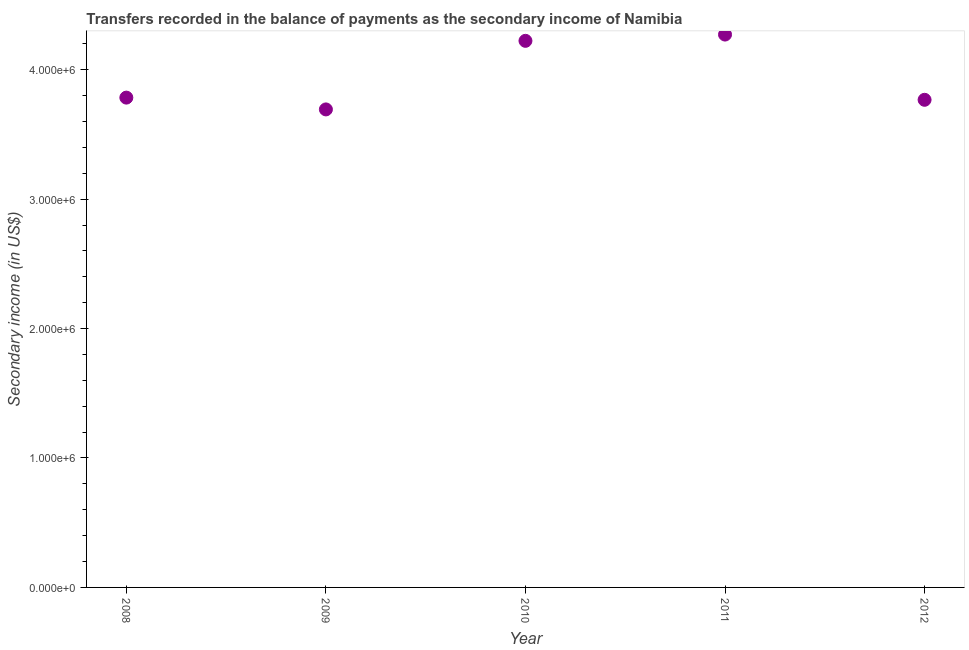What is the amount of secondary income in 2012?
Provide a short and direct response. 3.77e+06. Across all years, what is the maximum amount of secondary income?
Give a very brief answer. 4.27e+06. Across all years, what is the minimum amount of secondary income?
Provide a short and direct response. 3.69e+06. In which year was the amount of secondary income minimum?
Your answer should be compact. 2009. What is the sum of the amount of secondary income?
Offer a terse response. 1.97e+07. What is the difference between the amount of secondary income in 2010 and 2011?
Make the answer very short. -4.85e+04. What is the average amount of secondary income per year?
Your answer should be compact. 3.95e+06. What is the median amount of secondary income?
Your response must be concise. 3.78e+06. What is the ratio of the amount of secondary income in 2009 to that in 2010?
Offer a very short reply. 0.87. Is the amount of secondary income in 2008 less than that in 2011?
Give a very brief answer. Yes. Is the difference between the amount of secondary income in 2009 and 2010 greater than the difference between any two years?
Give a very brief answer. No. What is the difference between the highest and the second highest amount of secondary income?
Your answer should be very brief. 4.85e+04. Is the sum of the amount of secondary income in 2008 and 2009 greater than the maximum amount of secondary income across all years?
Provide a short and direct response. Yes. What is the difference between the highest and the lowest amount of secondary income?
Your answer should be compact. 5.78e+05. Does the amount of secondary income monotonically increase over the years?
Offer a very short reply. No. How many years are there in the graph?
Give a very brief answer. 5. What is the difference between two consecutive major ticks on the Y-axis?
Keep it short and to the point. 1.00e+06. Are the values on the major ticks of Y-axis written in scientific E-notation?
Provide a short and direct response. Yes. What is the title of the graph?
Your response must be concise. Transfers recorded in the balance of payments as the secondary income of Namibia. What is the label or title of the X-axis?
Give a very brief answer. Year. What is the label or title of the Y-axis?
Your answer should be compact. Secondary income (in US$). What is the Secondary income (in US$) in 2008?
Your answer should be very brief. 3.78e+06. What is the Secondary income (in US$) in 2009?
Give a very brief answer. 3.69e+06. What is the Secondary income (in US$) in 2010?
Make the answer very short. 4.22e+06. What is the Secondary income (in US$) in 2011?
Keep it short and to the point. 4.27e+06. What is the Secondary income (in US$) in 2012?
Offer a terse response. 3.77e+06. What is the difference between the Secondary income (in US$) in 2008 and 2009?
Offer a terse response. 9.12e+04. What is the difference between the Secondary income (in US$) in 2008 and 2010?
Your answer should be very brief. -4.39e+05. What is the difference between the Secondary income (in US$) in 2008 and 2011?
Provide a short and direct response. -4.87e+05. What is the difference between the Secondary income (in US$) in 2008 and 2012?
Make the answer very short. 1.69e+04. What is the difference between the Secondary income (in US$) in 2009 and 2010?
Provide a succinct answer. -5.30e+05. What is the difference between the Secondary income (in US$) in 2009 and 2011?
Provide a short and direct response. -5.78e+05. What is the difference between the Secondary income (in US$) in 2009 and 2012?
Provide a succinct answer. -7.42e+04. What is the difference between the Secondary income (in US$) in 2010 and 2011?
Offer a very short reply. -4.85e+04. What is the difference between the Secondary income (in US$) in 2010 and 2012?
Keep it short and to the point. 4.56e+05. What is the difference between the Secondary income (in US$) in 2011 and 2012?
Your answer should be very brief. 5.04e+05. What is the ratio of the Secondary income (in US$) in 2008 to that in 2010?
Keep it short and to the point. 0.9. What is the ratio of the Secondary income (in US$) in 2008 to that in 2011?
Your answer should be very brief. 0.89. What is the ratio of the Secondary income (in US$) in 2008 to that in 2012?
Your answer should be compact. 1. What is the ratio of the Secondary income (in US$) in 2009 to that in 2010?
Offer a terse response. 0.88. What is the ratio of the Secondary income (in US$) in 2009 to that in 2011?
Give a very brief answer. 0.86. What is the ratio of the Secondary income (in US$) in 2010 to that in 2012?
Ensure brevity in your answer.  1.12. What is the ratio of the Secondary income (in US$) in 2011 to that in 2012?
Keep it short and to the point. 1.13. 